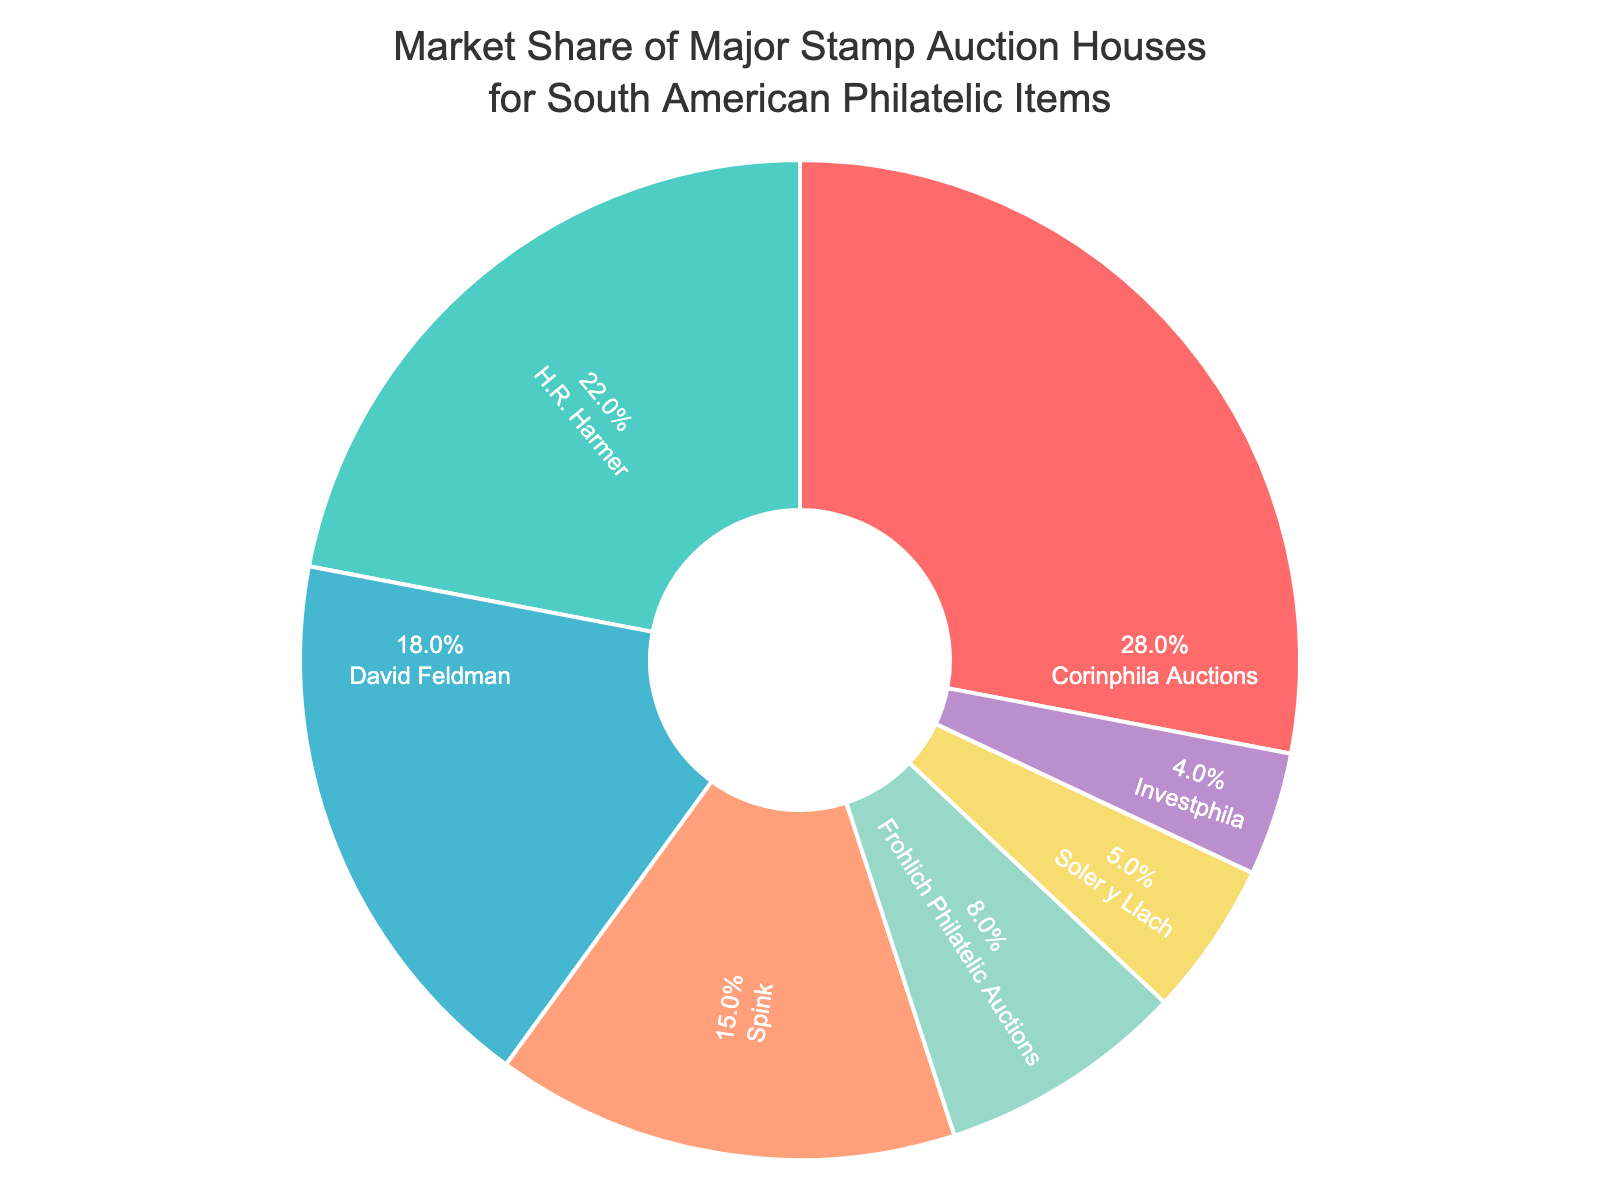What's the market share of H.R. Harmer? In the pie chart, the segment labeled "H.R. Harmer" has a market share percentage shown inside the segment. You can read this value directly.
Answer: 22% Which company has the second-largest market share? Look at the pie chart and identify the segment with the second-largest area after Corinphila Auctions. The percentage inside this segment belongs to H.R. Harmer.
Answer: H.R. Harmer How much larger is Corinphila Auctions' market share than Soler y Llach's? Subtract Soler y Llach's market share from Corinphila Auctions' market share: 28% - 5% = 23%.
Answer: 23% Which companies have a combined market share of less than 10%? Look at the market shares of Frohlich Philatelic Auctions, Soler y Llach, and Investphila. Summing these values: 8% + 5% + 4% = 17%. Only Investphila meets the criterion.
Answer: Investphila What is the percentage of the total market covered by the top three auction houses? Add the market shares of Corinphila Auctions, H.R. Harmer, and David Feldman: 28% + 22% + 18% = 68%.
Answer: 68% Who has the smallest market share, and what is it? Identify the segment with the smallest percentage value. This is the segment for Investphila with a 4% market share.
Answer: Investphila, 4% What is the difference in market share between David Feldman and Spink? Subtract Spink's market share from David Feldman's market share: 18% - 15% = 3%.
Answer: 3% What color represents Frohlich Philatelic Auctions on the pie chart? Identify the segment labeled Frohlich Philatelic Auctions and note its color.
Answer: Light Gray How does the combined market share of the two smallest companies compare to Frohlich Philatelic Auctions? Add the market shares of Soler y Llach and Investphila: 5% + 4% = 9%. Compare this with Frohlich Philatelic Auctions' 8%. 9% is greater than 8%.
Answer: Greater 